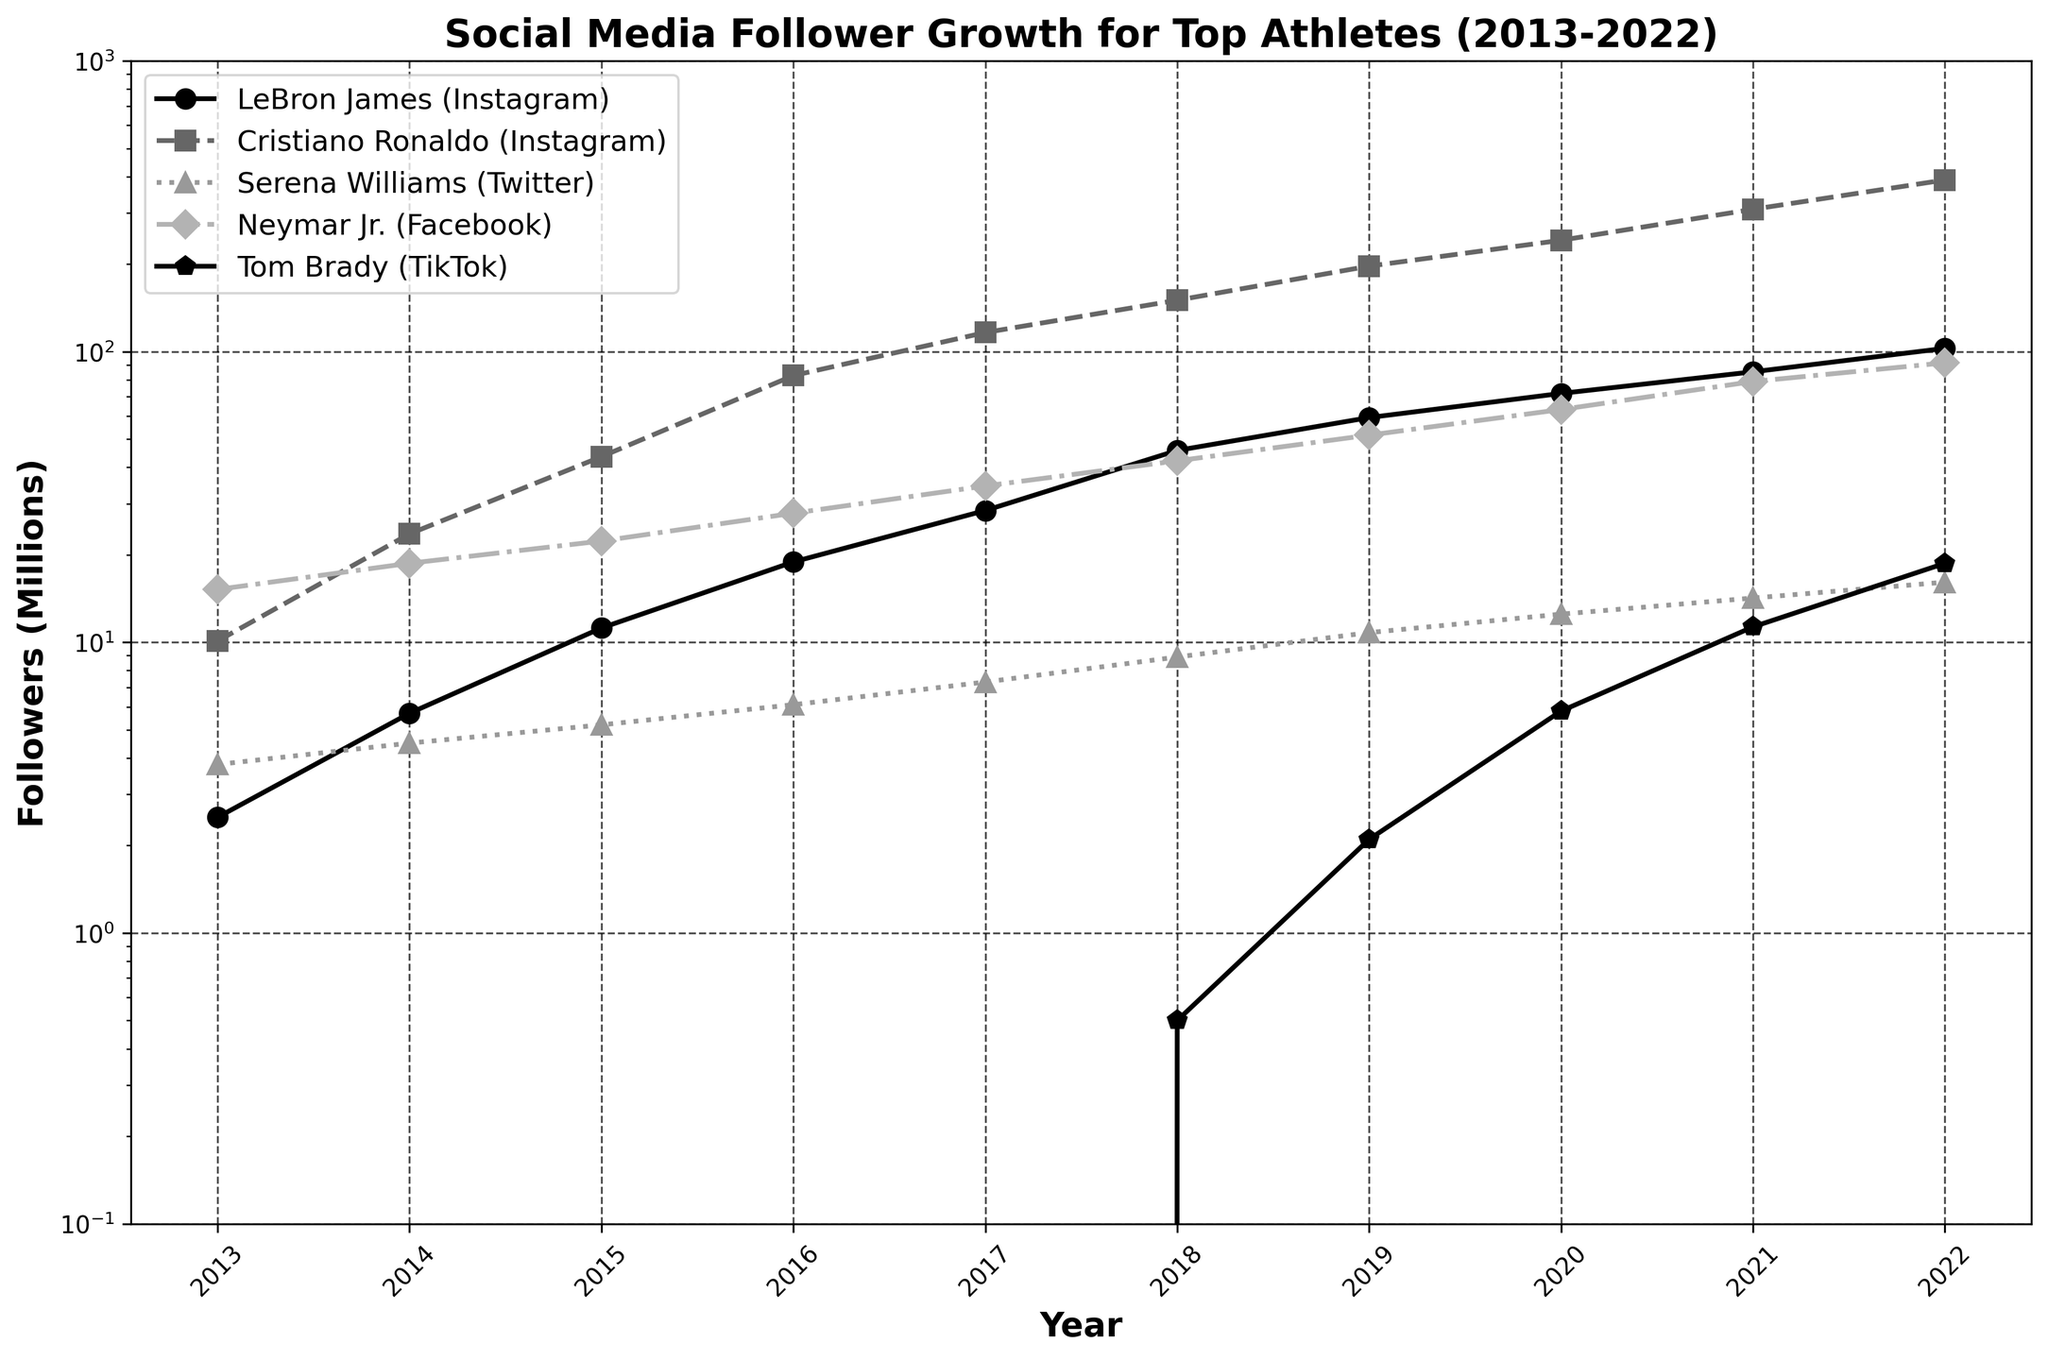Which athlete had the highest follower growth on Instagram by 2022? To find the athlete with the highest follower growth, observe the line chart and identify the highest endpoint on the y-axis in 2022. Cristiano Ronaldo's Instagram has the highest value.
Answer: Cristiano Ronaldo What is the difference in follower count between Neymar Jr. on Facebook and Serena Williams on Twitter in 2019? Locate the value for Neymar Jr. on Facebook in 2019 (51.6 million), then locate the value for Serena Williams on Twitter in 2019 (10.8 million). Subtract Serena's followers from Neymar's. 51.6 - 10.8 = 40.8
Answer: 40.8 million How many platforms reached at least 100 million followers by 2021? Check the values for 2021 and count the number of platforms with values equal to or greater than 100 million. Cristiano Ronaldo (308.7 million) and LeBron James (85.2 million) were the only ones close, but only Cristiano Ronaldo reached more than 100 million.
Answer: 1 Which athlete saw the most consistent yearly increase in followers across the decade? Examine each line's slope over time. Cristiano Ronaldo's line shows a steep, consistent increase over time.
Answer: Cristiano Ronaldo From 2018 to 2020, what was the average annual follower gain for LeBron James on Instagram? Determine the follower count for LeBron James in 2018 and 2020 (45.7 million and 71.8 million, respectively). Subtract 2018's count from 2020's count, then divide by the number of years (2). (71.8 - 45.7) / 2 = 13.05
Answer: 13.05 million Which platform exhibited a dramatic rise in followers between 2017 and 2018? Observe the slope between 2017 and 2018 for all lines. LeBron James on Instagram shows a dramatic rise from 28.4 million to 45.7 million.
Answer: LeBron James (Instagram) How much did Tom Brady's TikTok following grow from 2019 to 2022? Identify Tom Brady's TikTok follower count in 2019 (2.1 million) and 2022 (18.7 million). Subtract 2019's count from 2022's count. 18.7 - 2.1 = 16.6
Answer: 16.6 million 